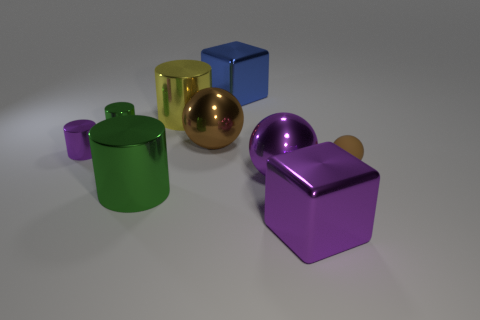How many brown spheres must be subtracted to get 1 brown spheres? 1 Subtract 1 cylinders. How many cylinders are left? 3 Subtract all balls. How many objects are left? 6 Add 9 large purple rubber balls. How many large purple rubber balls exist? 9 Subtract 2 brown balls. How many objects are left? 7 Subtract all cylinders. Subtract all large purple shiny balls. How many objects are left? 4 Add 4 large brown spheres. How many large brown spheres are left? 5 